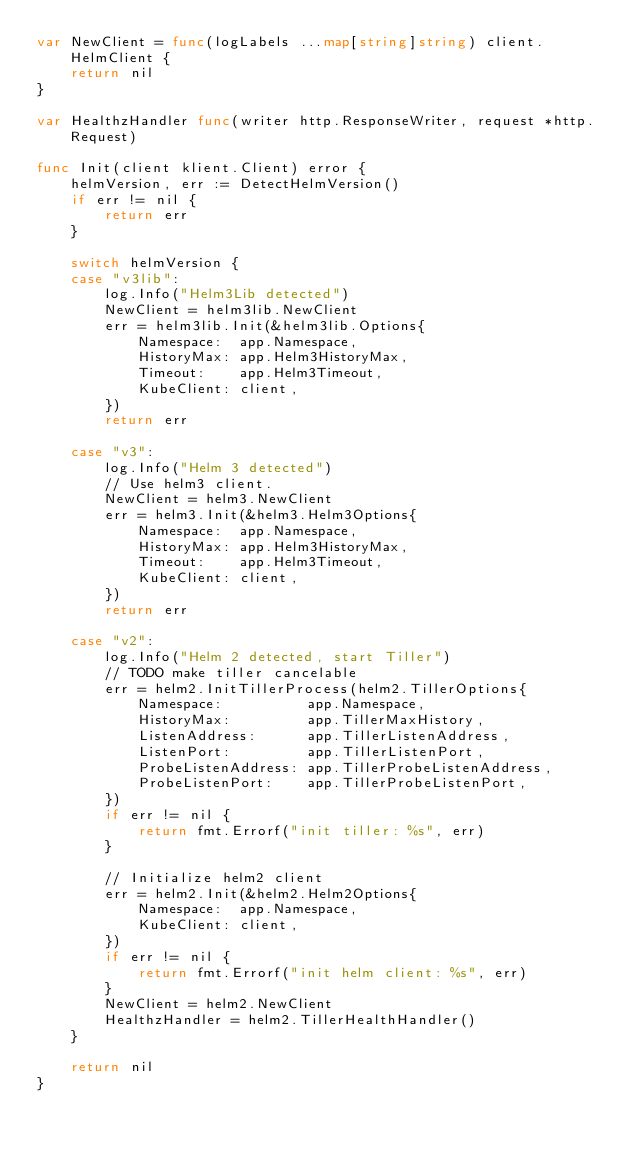Convert code to text. <code><loc_0><loc_0><loc_500><loc_500><_Go_>var NewClient = func(logLabels ...map[string]string) client.HelmClient {
	return nil
}

var HealthzHandler func(writer http.ResponseWriter, request *http.Request)

func Init(client klient.Client) error {
	helmVersion, err := DetectHelmVersion()
	if err != nil {
		return err
	}

	switch helmVersion {
	case "v3lib":
		log.Info("Helm3Lib detected")
		NewClient = helm3lib.NewClient
		err = helm3lib.Init(&helm3lib.Options{
			Namespace:  app.Namespace,
			HistoryMax: app.Helm3HistoryMax,
			Timeout:    app.Helm3Timeout,
			KubeClient: client,
		})
		return err

	case "v3":
		log.Info("Helm 3 detected")
		// Use helm3 client.
		NewClient = helm3.NewClient
		err = helm3.Init(&helm3.Helm3Options{
			Namespace:  app.Namespace,
			HistoryMax: app.Helm3HistoryMax,
			Timeout:    app.Helm3Timeout,
			KubeClient: client,
		})
		return err

	case "v2":
		log.Info("Helm 2 detected, start Tiller")
		// TODO make tiller cancelable
		err = helm2.InitTillerProcess(helm2.TillerOptions{
			Namespace:          app.Namespace,
			HistoryMax:         app.TillerMaxHistory,
			ListenAddress:      app.TillerListenAddress,
			ListenPort:         app.TillerListenPort,
			ProbeListenAddress: app.TillerProbeListenAddress,
			ProbeListenPort:    app.TillerProbeListenPort,
		})
		if err != nil {
			return fmt.Errorf("init tiller: %s", err)
		}

		// Initialize helm2 client
		err = helm2.Init(&helm2.Helm2Options{
			Namespace:  app.Namespace,
			KubeClient: client,
		})
		if err != nil {
			return fmt.Errorf("init helm client: %s", err)
		}
		NewClient = helm2.NewClient
		HealthzHandler = helm2.TillerHealthHandler()
	}

	return nil
}
</code> 